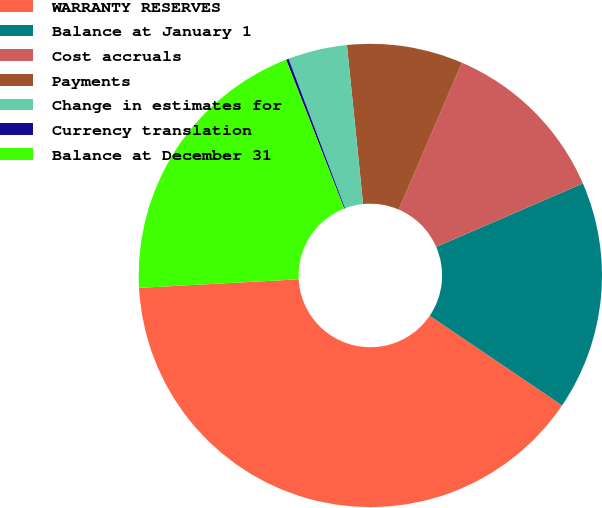Convert chart to OTSL. <chart><loc_0><loc_0><loc_500><loc_500><pie_chart><fcel>WARRANTY RESERVES<fcel>Balance at January 1<fcel>Cost accruals<fcel>Payments<fcel>Change in estimates for<fcel>Currency translation<fcel>Balance at December 31<nl><fcel>39.67%<fcel>15.98%<fcel>12.03%<fcel>8.08%<fcel>4.13%<fcel>0.18%<fcel>19.93%<nl></chart> 